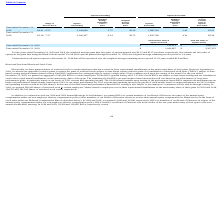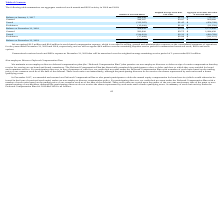According to Luna Innovations Incorporated's financial document, What was the Balance at December 31, 2018 for the number of unvested shares? According to the financial document, 458,620. The relevant text states: "Balance at December 31, 2018 458,620 $2.56 $ 1,172,456..." Also, can you calculate: What is the change in Number of Unvested Shares from Balance at January 1, 2017 to December 31, 2018? Based on the calculation: 458,620-489,698, the result is -31078. This is based on the information: "Balance at January 1, 2017 489,698 $1.51 $ 738,345 Balance at December 31, 2018 458,620 $2.56 $ 1,172,456..." The key data points involved are: 458,620, 489,698. Also, can you calculate: What is the average Number of Unvested Shares for Balance for January 1, 2017 and December 31, 2018? To answer this question, I need to perform calculations using the financial data. The calculation is: (458,620+489,698) / 2, which equals 474159. This is based on the information: "Balance at January 1, 2017 489,698 $1.51 $ 738,345 Balance at December 31, 2018 458,620 $2.56 $ 1,172,456..." The key data points involved are: 458,620, 489,698. Also, What was the number of unvested shares Granted in 2018 and 2019 respectively? The document shows two values: 296,287 and 291,600. From the document: "Granted 296,287 $3.07 $ 909,600 Granted 291,600 $3.75 $ 1,094,430..." Also, What was the Balance at December 31, 2019 for the number of unvested shares? According to the financial document, 502,102. The relevant text states: "Balance at December 31, 2019 502,102 $3.32 $ 1,665,002..." Also, can you calculate: What is the change in Weighted Average Grant Date Fair Value between the unvested shares in January 1, 2017 and those at December 31, 2018? Based on the calculation: 1.51-2.56, the result is -1.05. This is based on the information: "Balance at January 1, 2017 489,698 $1.51 $ 738,345 Balance at December 31, 2018 458,620 $2.56 $ 1,172,456..." The key data points involved are: 1.51, 2.56. 